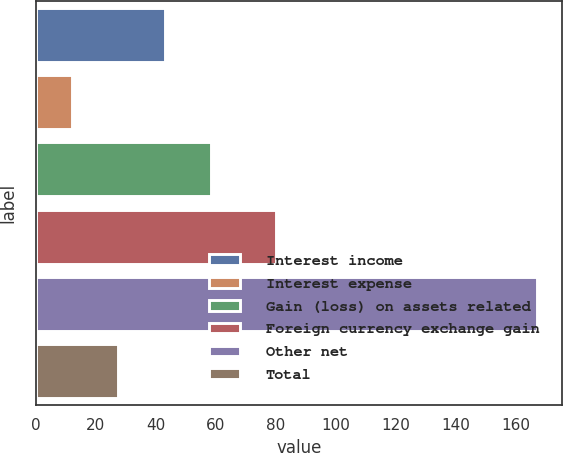Convert chart to OTSL. <chart><loc_0><loc_0><loc_500><loc_500><bar_chart><fcel>Interest income<fcel>Interest expense<fcel>Gain (loss) on assets related<fcel>Foreign currency exchange gain<fcel>Other net<fcel>Total<nl><fcel>43<fcel>12<fcel>58.5<fcel>80<fcel>167<fcel>27.5<nl></chart> 